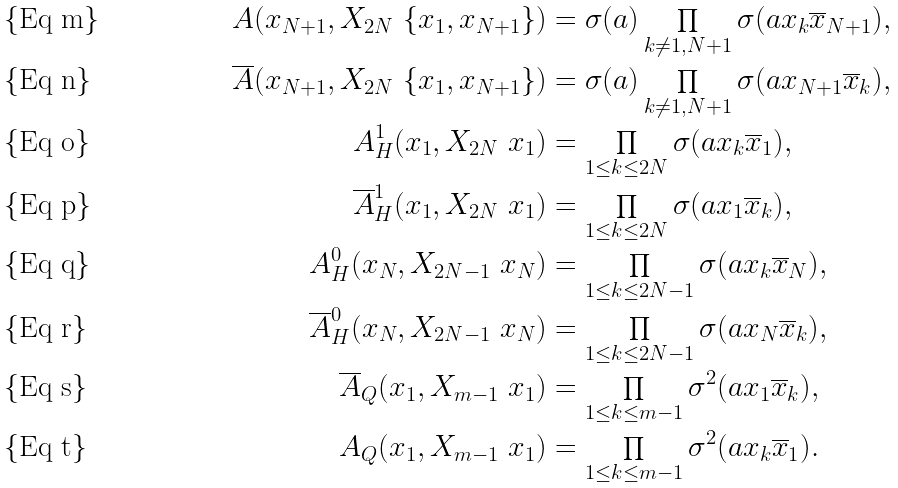Convert formula to latex. <formula><loc_0><loc_0><loc_500><loc_500>A ( x _ { N + 1 } , X _ { 2 N } \ \{ x _ { 1 } , x _ { N + 1 } \} ) & = \sigma ( a ) \prod _ { k \neq 1 , N + 1 } \sigma ( a x _ { k } \overline { x } _ { N + 1 } ) , \\ \overline { A } ( x _ { N + 1 } , X _ { 2 N } \ \{ x _ { 1 } , x _ { N + 1 } \} ) & = \sigma ( a ) \prod _ { k \neq 1 , N + 1 } \sigma ( a x _ { N + 1 } \overline { x } _ { k } ) , \\ A _ { H } ^ { 1 } ( x _ { 1 } , X _ { 2 N } \ x _ { 1 } ) & = \prod _ { 1 \leq k \leq 2 N } \sigma ( a x _ { k } \overline { x } _ { 1 } ) , \\ \overline { A } _ { H } ^ { 1 } ( x _ { 1 } , X _ { 2 N } \ x _ { 1 } ) & = \prod _ { 1 \leq k \leq 2 N } \sigma ( a x _ { 1 } \overline { x } _ { k } ) , \\ A _ { H } ^ { 0 } ( x _ { N } , X _ { 2 N - 1 } \ x _ { N } ) & = \prod _ { 1 \leq k \leq 2 N - 1 } \sigma ( a x _ { k } \overline { x } _ { N } ) , \\ \overline { A } _ { H } ^ { 0 } ( x _ { N } , X _ { 2 N - 1 } \ x _ { N } ) & = \prod _ { 1 \leq k \leq 2 N - 1 } \sigma ( a x _ { N } \overline { x } _ { k } ) , \\ \overline { A } _ { Q } ( x _ { 1 } , X _ { m - 1 } \ x _ { 1 } ) & = \prod _ { 1 \leq k \leq m - 1 } \sigma ^ { 2 } ( a x _ { 1 } \overline { x } _ { k } ) , \\ A _ { Q } ( x _ { 1 } , X _ { m - 1 } \ x _ { 1 } ) & = \prod _ { 1 \leq k \leq m - 1 } \sigma ^ { 2 } ( a x _ { k } \overline { x } _ { 1 } ) .</formula> 